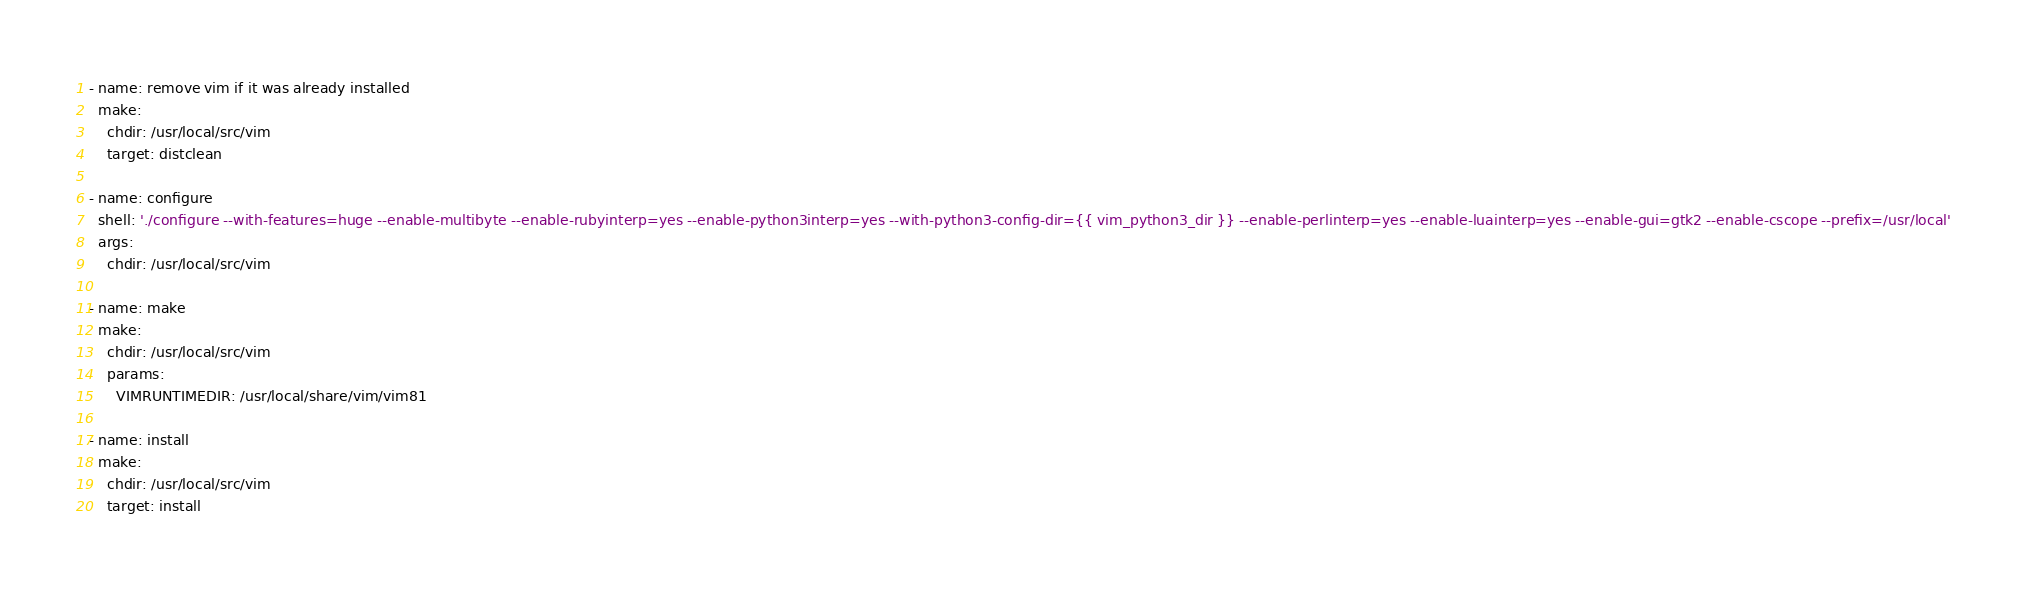<code> <loc_0><loc_0><loc_500><loc_500><_YAML_>- name: remove vim if it was already installed
  make:
    chdir: /usr/local/src/vim
    target: distclean

- name: configure
  shell: './configure --with-features=huge --enable-multibyte --enable-rubyinterp=yes --enable-python3interp=yes --with-python3-config-dir={{ vim_python3_dir }} --enable-perlinterp=yes --enable-luainterp=yes --enable-gui=gtk2 --enable-cscope --prefix=/usr/local'
  args:
    chdir: /usr/local/src/vim

- name: make
  make:
    chdir: /usr/local/src/vim
    params:
      VIMRUNTIMEDIR: /usr/local/share/vim/vim81

- name: install
  make:
    chdir: /usr/local/src/vim
    target: install
</code> 